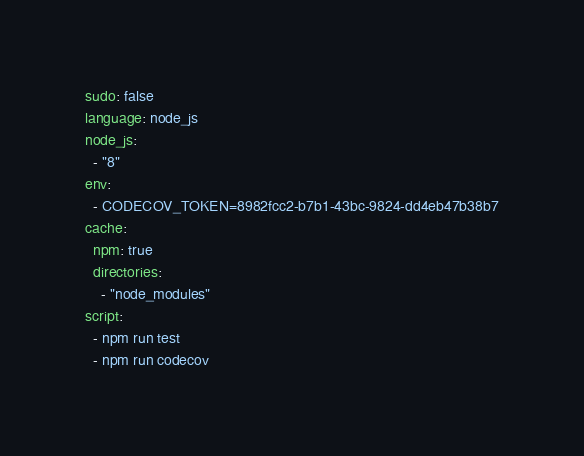<code> <loc_0><loc_0><loc_500><loc_500><_YAML_>sudo: false
language: node_js
node_js:
  - "8"
env:
  - CODECOV_TOKEN=8982fcc2-b7b1-43bc-9824-dd4eb47b38b7
cache:
  npm: true
  directories:
    - "node_modules"
script:
  - npm run test
  - npm run codecov
</code> 